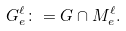Convert formula to latex. <formula><loc_0><loc_0><loc_500><loc_500>G _ { e } ^ { \ell } \colon = G \cap M _ { e } ^ { \ell } .</formula> 